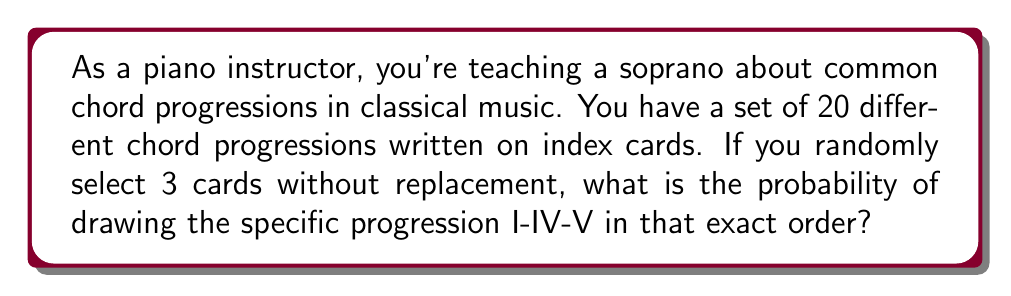Give your solution to this math problem. Let's approach this step-by-step:

1) We need to select 3 specific cards in a specific order out of 20 cards.

2) For the first card (I chord):
   - There is only 1 correct choice out of 20 cards.
   - Probability: $\frac{1}{20}$

3) For the second card (IV chord):
   - There are now 19 cards left, and we need the specific IV card.
   - Probability: $\frac{1}{19}$

4) For the third card (V chord):
   - There are now 18 cards left, and we need the specific V card.
   - Probability: $\frac{1}{18}$

5) To get the probability of all these events occurring in this specific order, we multiply these individual probabilities:

   $$P(\text{I-IV-V in order}) = \frac{1}{20} \times \frac{1}{19} \times \frac{1}{18}$$

6) Simplifying:
   $$P(\text{I-IV-V in order}) = \frac{1}{20 \times 19 \times 18} = \frac{1}{6840}$$

Therefore, the probability of randomly selecting the I-IV-V progression in that exact order is $\frac{1}{6840}$.
Answer: $\frac{1}{6840}$ 